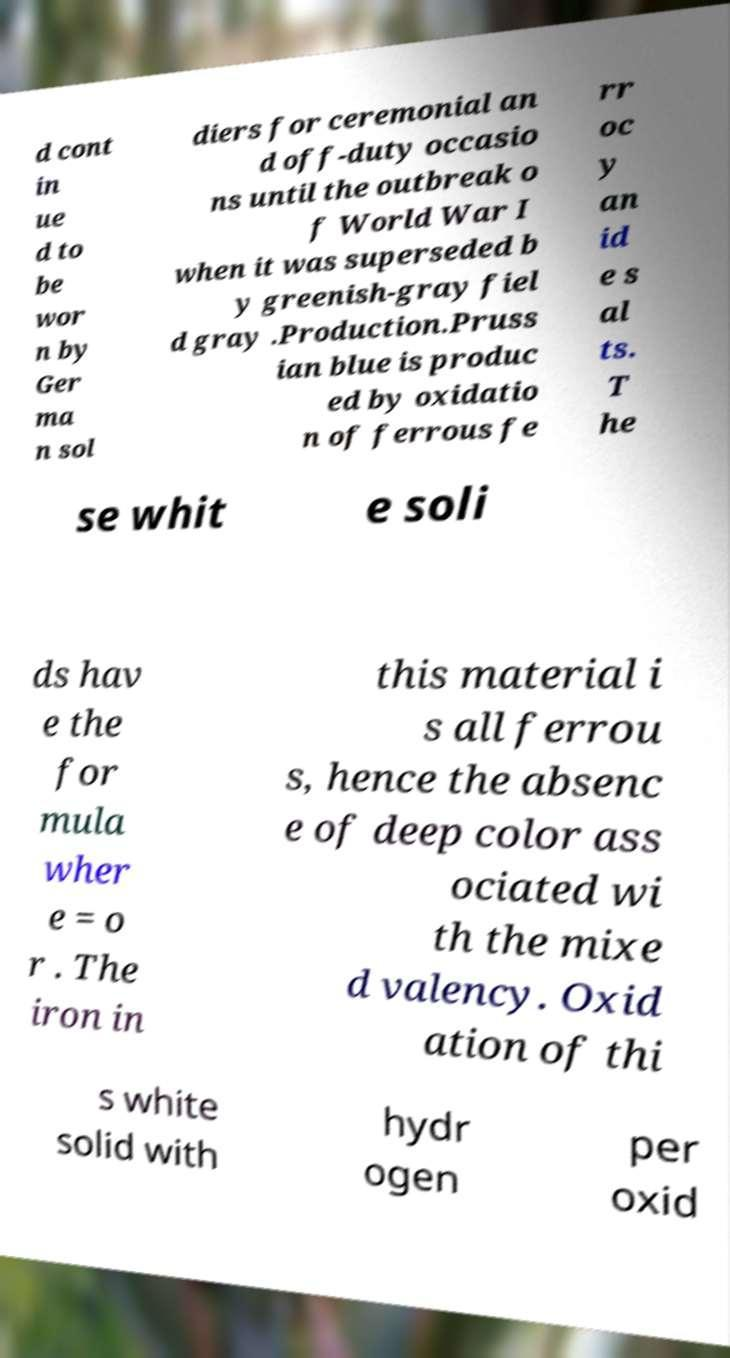Can you accurately transcribe the text from the provided image for me? d cont in ue d to be wor n by Ger ma n sol diers for ceremonial an d off-duty occasio ns until the outbreak o f World War I when it was superseded b y greenish-gray fiel d gray .Production.Pruss ian blue is produc ed by oxidatio n of ferrous fe rr oc y an id e s al ts. T he se whit e soli ds hav e the for mula wher e = o r . The iron in this material i s all ferrou s, hence the absenc e of deep color ass ociated wi th the mixe d valency. Oxid ation of thi s white solid with hydr ogen per oxid 